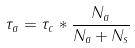<formula> <loc_0><loc_0><loc_500><loc_500>\tau _ { a } = \tau _ { c } * \frac { N _ { a } } { N _ { a } + N _ { s } }</formula> 